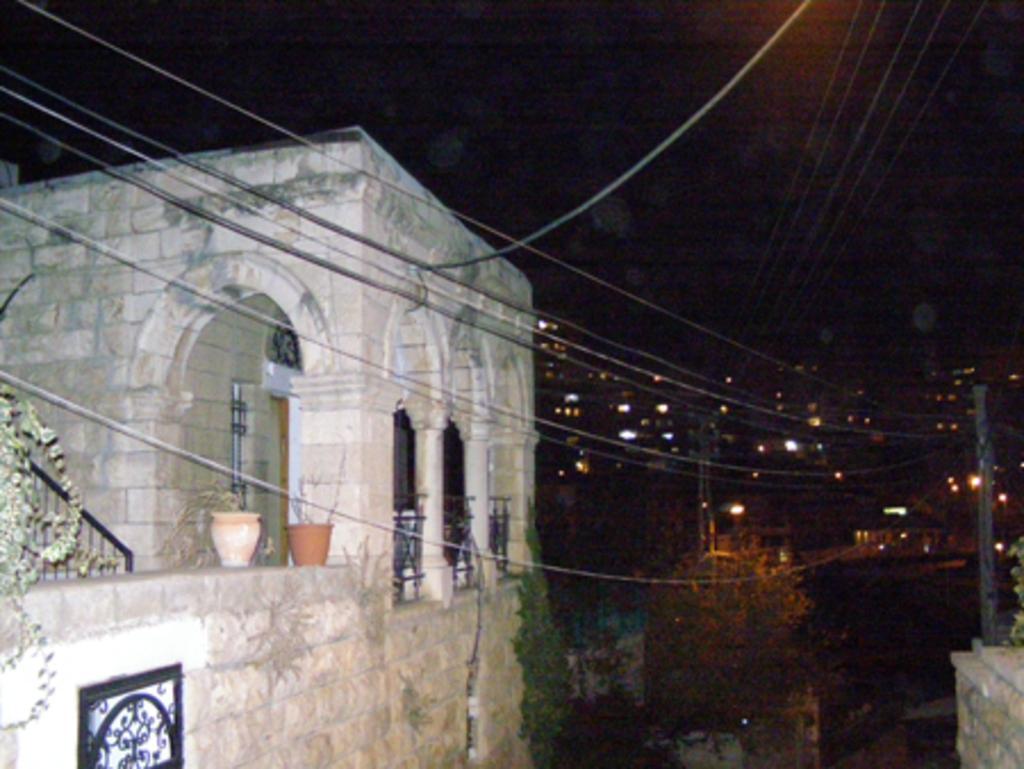Could you give a brief overview of what you see in this image? In the middle of the image we can see some buildings, trees, poles and wires. On the building we can see some plants. 